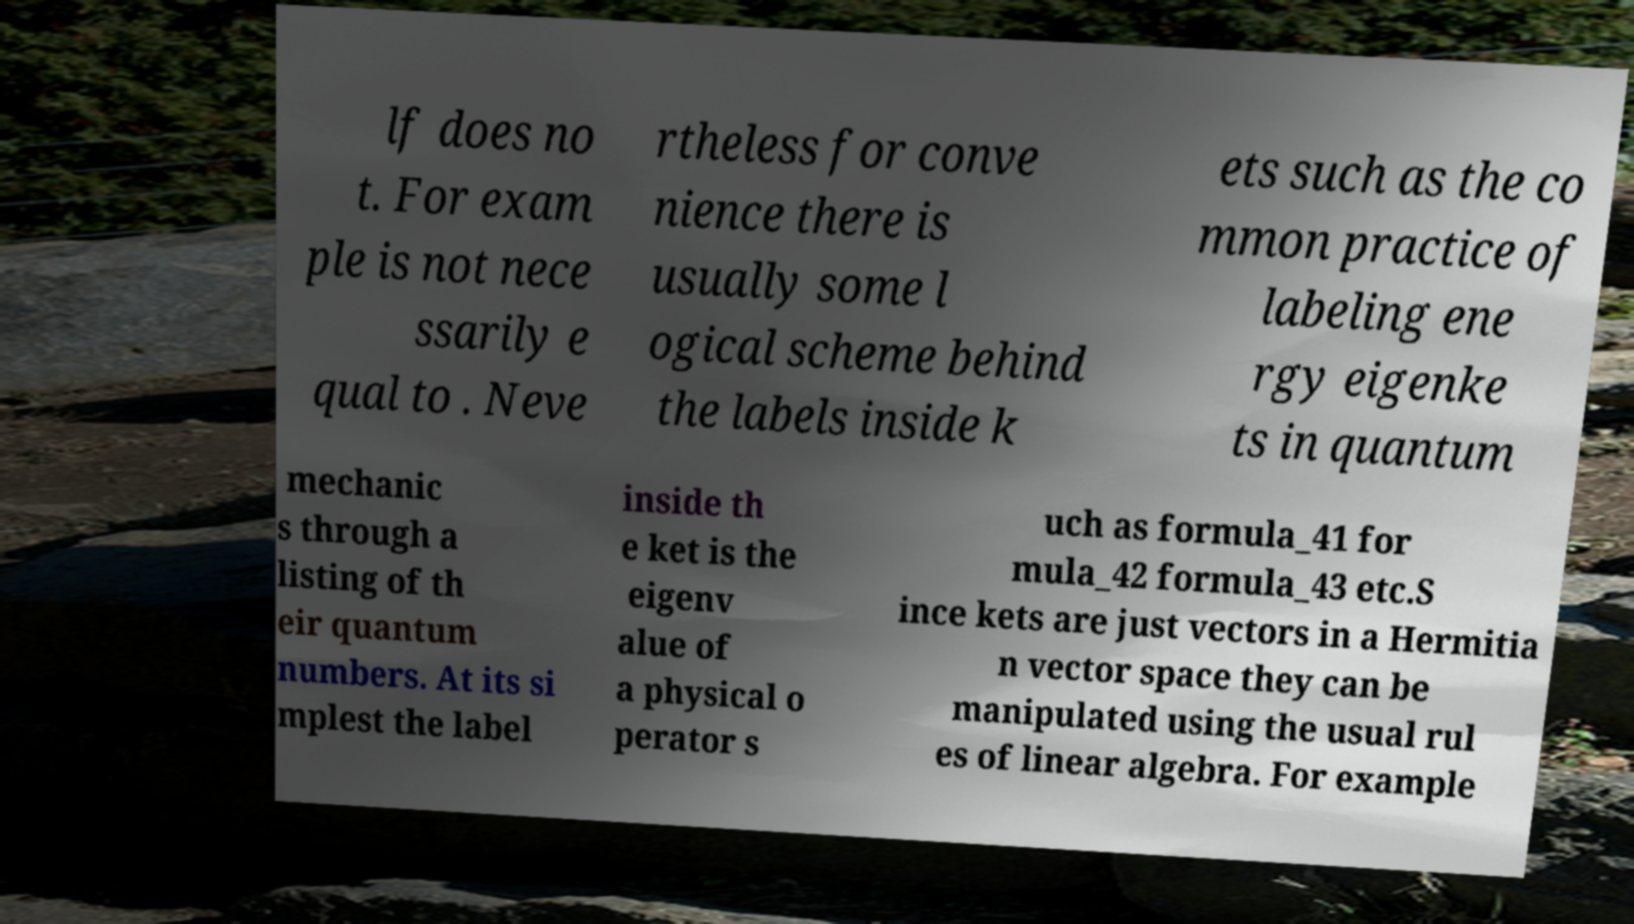Could you assist in decoding the text presented in this image and type it out clearly? lf does no t. For exam ple is not nece ssarily e qual to . Neve rtheless for conve nience there is usually some l ogical scheme behind the labels inside k ets such as the co mmon practice of labeling ene rgy eigenke ts in quantum mechanic s through a listing of th eir quantum numbers. At its si mplest the label inside th e ket is the eigenv alue of a physical o perator s uch as formula_41 for mula_42 formula_43 etc.S ince kets are just vectors in a Hermitia n vector space they can be manipulated using the usual rul es of linear algebra. For example 